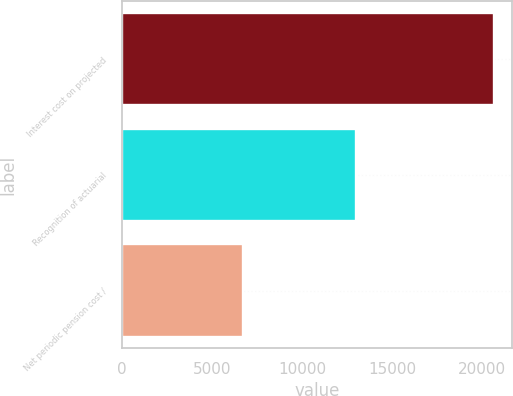Convert chart. <chart><loc_0><loc_0><loc_500><loc_500><bar_chart><fcel>Interest cost on projected<fcel>Recognition of actuarial<fcel>Net periodic pension cost /<nl><fcel>20641<fcel>13018<fcel>6753<nl></chart> 